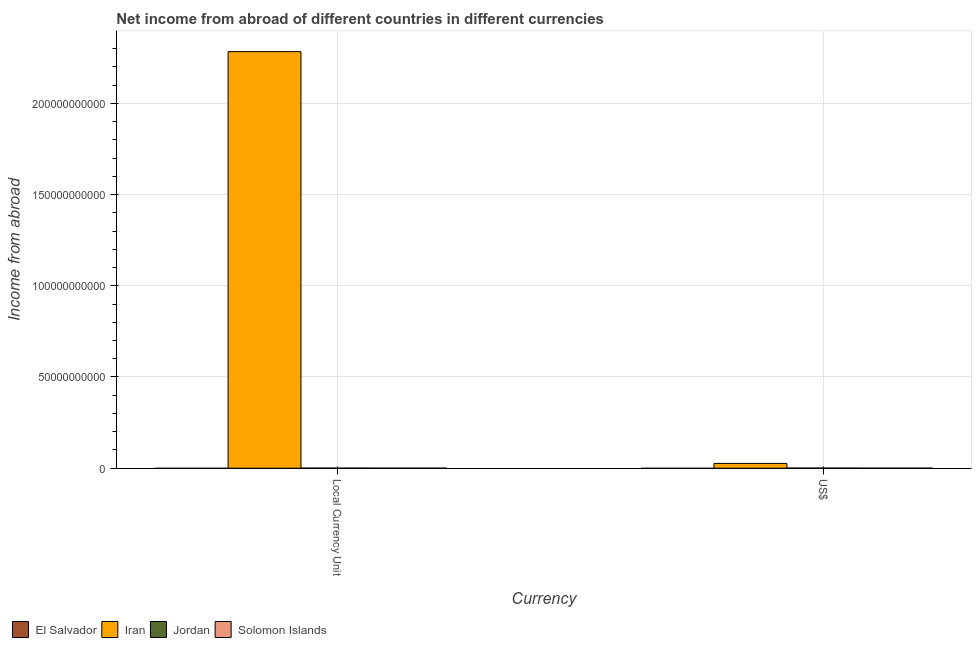How many groups of bars are there?
Give a very brief answer. 2. How many bars are there on the 1st tick from the right?
Ensure brevity in your answer.  2. What is the label of the 1st group of bars from the left?
Offer a terse response. Local Currency Unit. What is the income from abroad in constant 2005 us$ in El Salvador?
Offer a very short reply. 0. Across all countries, what is the maximum income from abroad in constant 2005 us$?
Ensure brevity in your answer.  2.28e+11. In which country was the income from abroad in constant 2005 us$ maximum?
Keep it short and to the point. Iran. What is the total income from abroad in us$ in the graph?
Give a very brief answer. 2.66e+09. What is the difference between the income from abroad in us$ in Iran and that in Jordan?
Keep it short and to the point. 2.57e+09. What is the difference between the income from abroad in constant 2005 us$ in Jordan and the income from abroad in us$ in El Salvador?
Your answer should be compact. 1.66e+07. What is the average income from abroad in constant 2005 us$ per country?
Ensure brevity in your answer.  5.71e+1. What is the difference between the income from abroad in constant 2005 us$ and income from abroad in us$ in Jordan?
Ensure brevity in your answer.  -2.91e+07. In how many countries, is the income from abroad in us$ greater than 100000000000 units?
Provide a short and direct response. 0. What is the ratio of the income from abroad in constant 2005 us$ in Iran to that in Jordan?
Offer a terse response. 1.38e+04. In how many countries, is the income from abroad in constant 2005 us$ greater than the average income from abroad in constant 2005 us$ taken over all countries?
Offer a terse response. 1. What is the difference between two consecutive major ticks on the Y-axis?
Give a very brief answer. 5.00e+1. Are the values on the major ticks of Y-axis written in scientific E-notation?
Keep it short and to the point. No. Does the graph contain any zero values?
Give a very brief answer. Yes. Does the graph contain grids?
Your answer should be compact. Yes. Where does the legend appear in the graph?
Provide a succinct answer. Bottom left. How many legend labels are there?
Keep it short and to the point. 4. How are the legend labels stacked?
Your answer should be compact. Horizontal. What is the title of the graph?
Ensure brevity in your answer.  Net income from abroad of different countries in different currencies. Does "Czech Republic" appear as one of the legend labels in the graph?
Your response must be concise. No. What is the label or title of the X-axis?
Offer a very short reply. Currency. What is the label or title of the Y-axis?
Make the answer very short. Income from abroad. What is the Income from abroad in El Salvador in Local Currency Unit?
Make the answer very short. 0. What is the Income from abroad of Iran in Local Currency Unit?
Ensure brevity in your answer.  2.28e+11. What is the Income from abroad in Jordan in Local Currency Unit?
Offer a very short reply. 1.66e+07. What is the Income from abroad in Iran in US$?
Your answer should be compact. 2.62e+09. What is the Income from abroad in Jordan in US$?
Your answer should be very brief. 4.56e+07. Across all Currency, what is the maximum Income from abroad in Iran?
Give a very brief answer. 2.28e+11. Across all Currency, what is the maximum Income from abroad in Jordan?
Provide a short and direct response. 4.56e+07. Across all Currency, what is the minimum Income from abroad of Iran?
Keep it short and to the point. 2.62e+09. Across all Currency, what is the minimum Income from abroad in Jordan?
Your answer should be very brief. 1.66e+07. What is the total Income from abroad in Iran in the graph?
Provide a succinct answer. 2.31e+11. What is the total Income from abroad of Jordan in the graph?
Offer a terse response. 6.22e+07. What is the total Income from abroad of Solomon Islands in the graph?
Your answer should be very brief. 0. What is the difference between the Income from abroad in Iran in Local Currency Unit and that in US$?
Make the answer very short. 2.26e+11. What is the difference between the Income from abroad in Jordan in Local Currency Unit and that in US$?
Give a very brief answer. -2.91e+07. What is the difference between the Income from abroad in Iran in Local Currency Unit and the Income from abroad in Jordan in US$?
Give a very brief answer. 2.28e+11. What is the average Income from abroad in Iran per Currency?
Give a very brief answer. 1.15e+11. What is the average Income from abroad in Jordan per Currency?
Offer a terse response. 3.11e+07. What is the average Income from abroad of Solomon Islands per Currency?
Your answer should be compact. 0. What is the difference between the Income from abroad in Iran and Income from abroad in Jordan in Local Currency Unit?
Provide a short and direct response. 2.28e+11. What is the difference between the Income from abroad of Iran and Income from abroad of Jordan in US$?
Your response must be concise. 2.57e+09. What is the ratio of the Income from abroad of Iran in Local Currency Unit to that in US$?
Keep it short and to the point. 87.23. What is the ratio of the Income from abroad in Jordan in Local Currency Unit to that in US$?
Your answer should be compact. 0.36. What is the difference between the highest and the second highest Income from abroad of Iran?
Your answer should be very brief. 2.26e+11. What is the difference between the highest and the second highest Income from abroad of Jordan?
Offer a very short reply. 2.91e+07. What is the difference between the highest and the lowest Income from abroad of Iran?
Provide a succinct answer. 2.26e+11. What is the difference between the highest and the lowest Income from abroad in Jordan?
Offer a very short reply. 2.91e+07. 